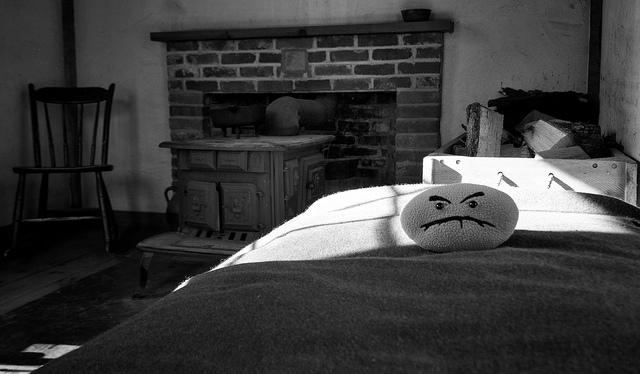What is in the left-hand corner?
Concise answer only. Chair. Is the furnace new or old?
Answer briefly. Old. Does the pillow on the bed have a smiley face?
Short answer required. No. 